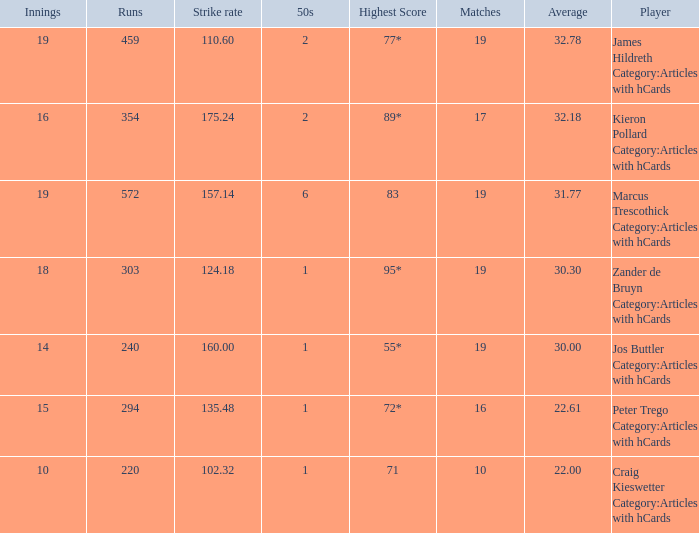How many innings for the player with an average of 22.61? 15.0. Could you parse the entire table? {'header': ['Innings', 'Runs', 'Strike rate', '50s', 'Highest Score', 'Matches', 'Average', 'Player'], 'rows': [['19', '459', '110.60', '2', '77*', '19', '32.78', 'James Hildreth Category:Articles with hCards'], ['16', '354', '175.24', '2', '89*', '17', '32.18', 'Kieron Pollard Category:Articles with hCards'], ['19', '572', '157.14', '6', '83', '19', '31.77', 'Marcus Trescothick Category:Articles with hCards'], ['18', '303', '124.18', '1', '95*', '19', '30.30', 'Zander de Bruyn Category:Articles with hCards'], ['14', '240', '160.00', '1', '55*', '19', '30.00', 'Jos Buttler Category:Articles with hCards'], ['15', '294', '135.48', '1', '72*', '16', '22.61', 'Peter Trego Category:Articles with hCards'], ['10', '220', '102.32', '1', '71', '10', '22.00', 'Craig Kieswetter Category:Articles with hCards']]} 